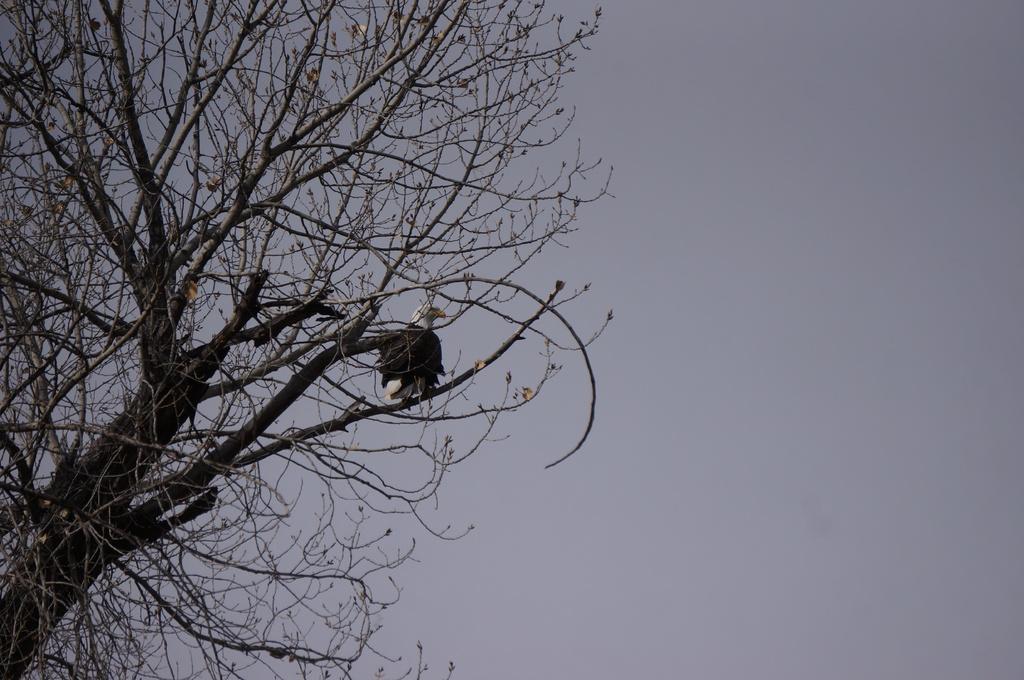How would you summarize this image in a sentence or two? In the image I can see a eagle sitting on the dry tree. Eagle is in brown and white color. The sky is in white color. 